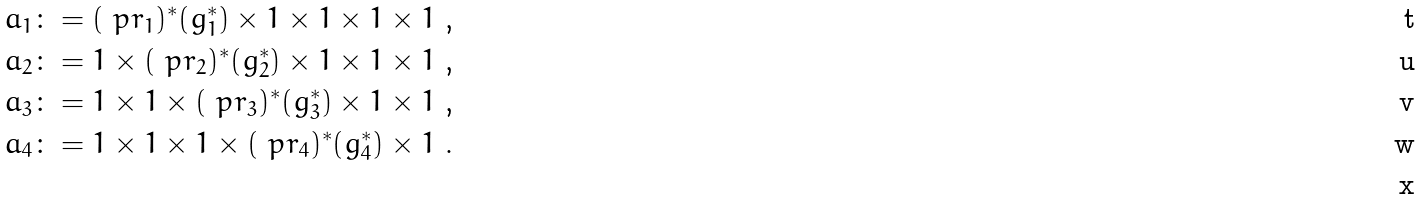<formula> <loc_0><loc_0><loc_500><loc_500>a _ { 1 } & \colon = ( \ p r _ { 1 } ) ^ { * } ( g _ { 1 } ^ { * } ) \times 1 \times 1 \times 1 \times 1 \text { ,} \\ a _ { 2 } & \colon = 1 \times ( \ p r _ { 2 } ) ^ { * } ( g _ { 2 } ^ { * } ) \times 1 \times 1 \times 1 \text { ,} \\ a _ { 3 } & \colon = 1 \times 1 \times ( \ p r _ { 3 } ) ^ { * } ( g _ { 3 } ^ { * } ) \times 1 \times 1 \text { ,} \\ a _ { 4 } & \colon = 1 \times 1 \times 1 \times ( \ p r _ { 4 } ) ^ { * } ( g _ { 4 } ^ { * } ) \times 1 \text { .} \\</formula> 